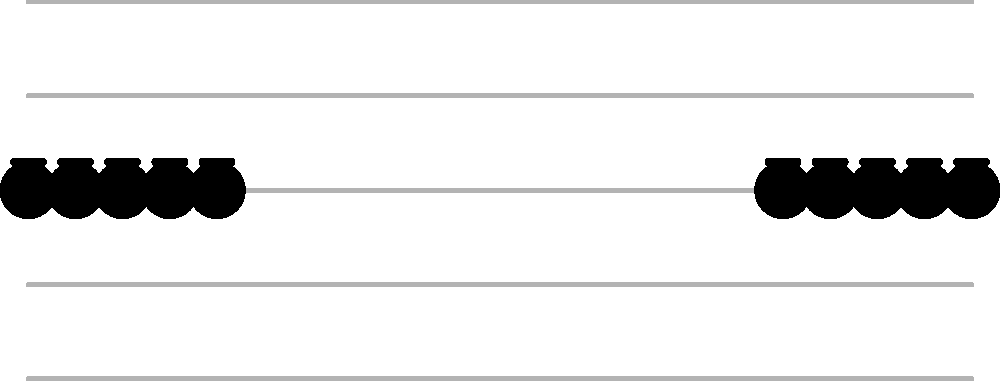In the musical staff shown above, which type of symmetry is exhibited by the arrangement of notes? To determine the type of symmetry in this musical notation, let's analyze the arrangement step-by-step:

1. Observe the placement of notes on the staff:
   - There are 5 notes on each side of the staff.
   - The notes are equally spaced on both sides.

2. Compare the left and right sides:
   - The leftmost note corresponds to the rightmost note.
   - The second note from the left corresponds to the second note from the right, and so on.

3. Imagine a vertical line drawn through the center of the staff:
   - This line would act as a mirror, with each note on the left having a corresponding note on the right at an equal distance from the center.

4. Notice that if we were to fold the image along this central vertical line, the notes on the left would perfectly align with the notes on the right.

5. This property, where one half of an image is a mirror image of the other half, is known as reflection symmetry or mirror symmetry.

6. In this case, the axis of symmetry is a vertical line through the center of the staff.

Therefore, the arrangement of notes exhibits reflection symmetry (also called mirror symmetry) about a vertical axis through the center of the staff.
Answer: Reflection symmetry 